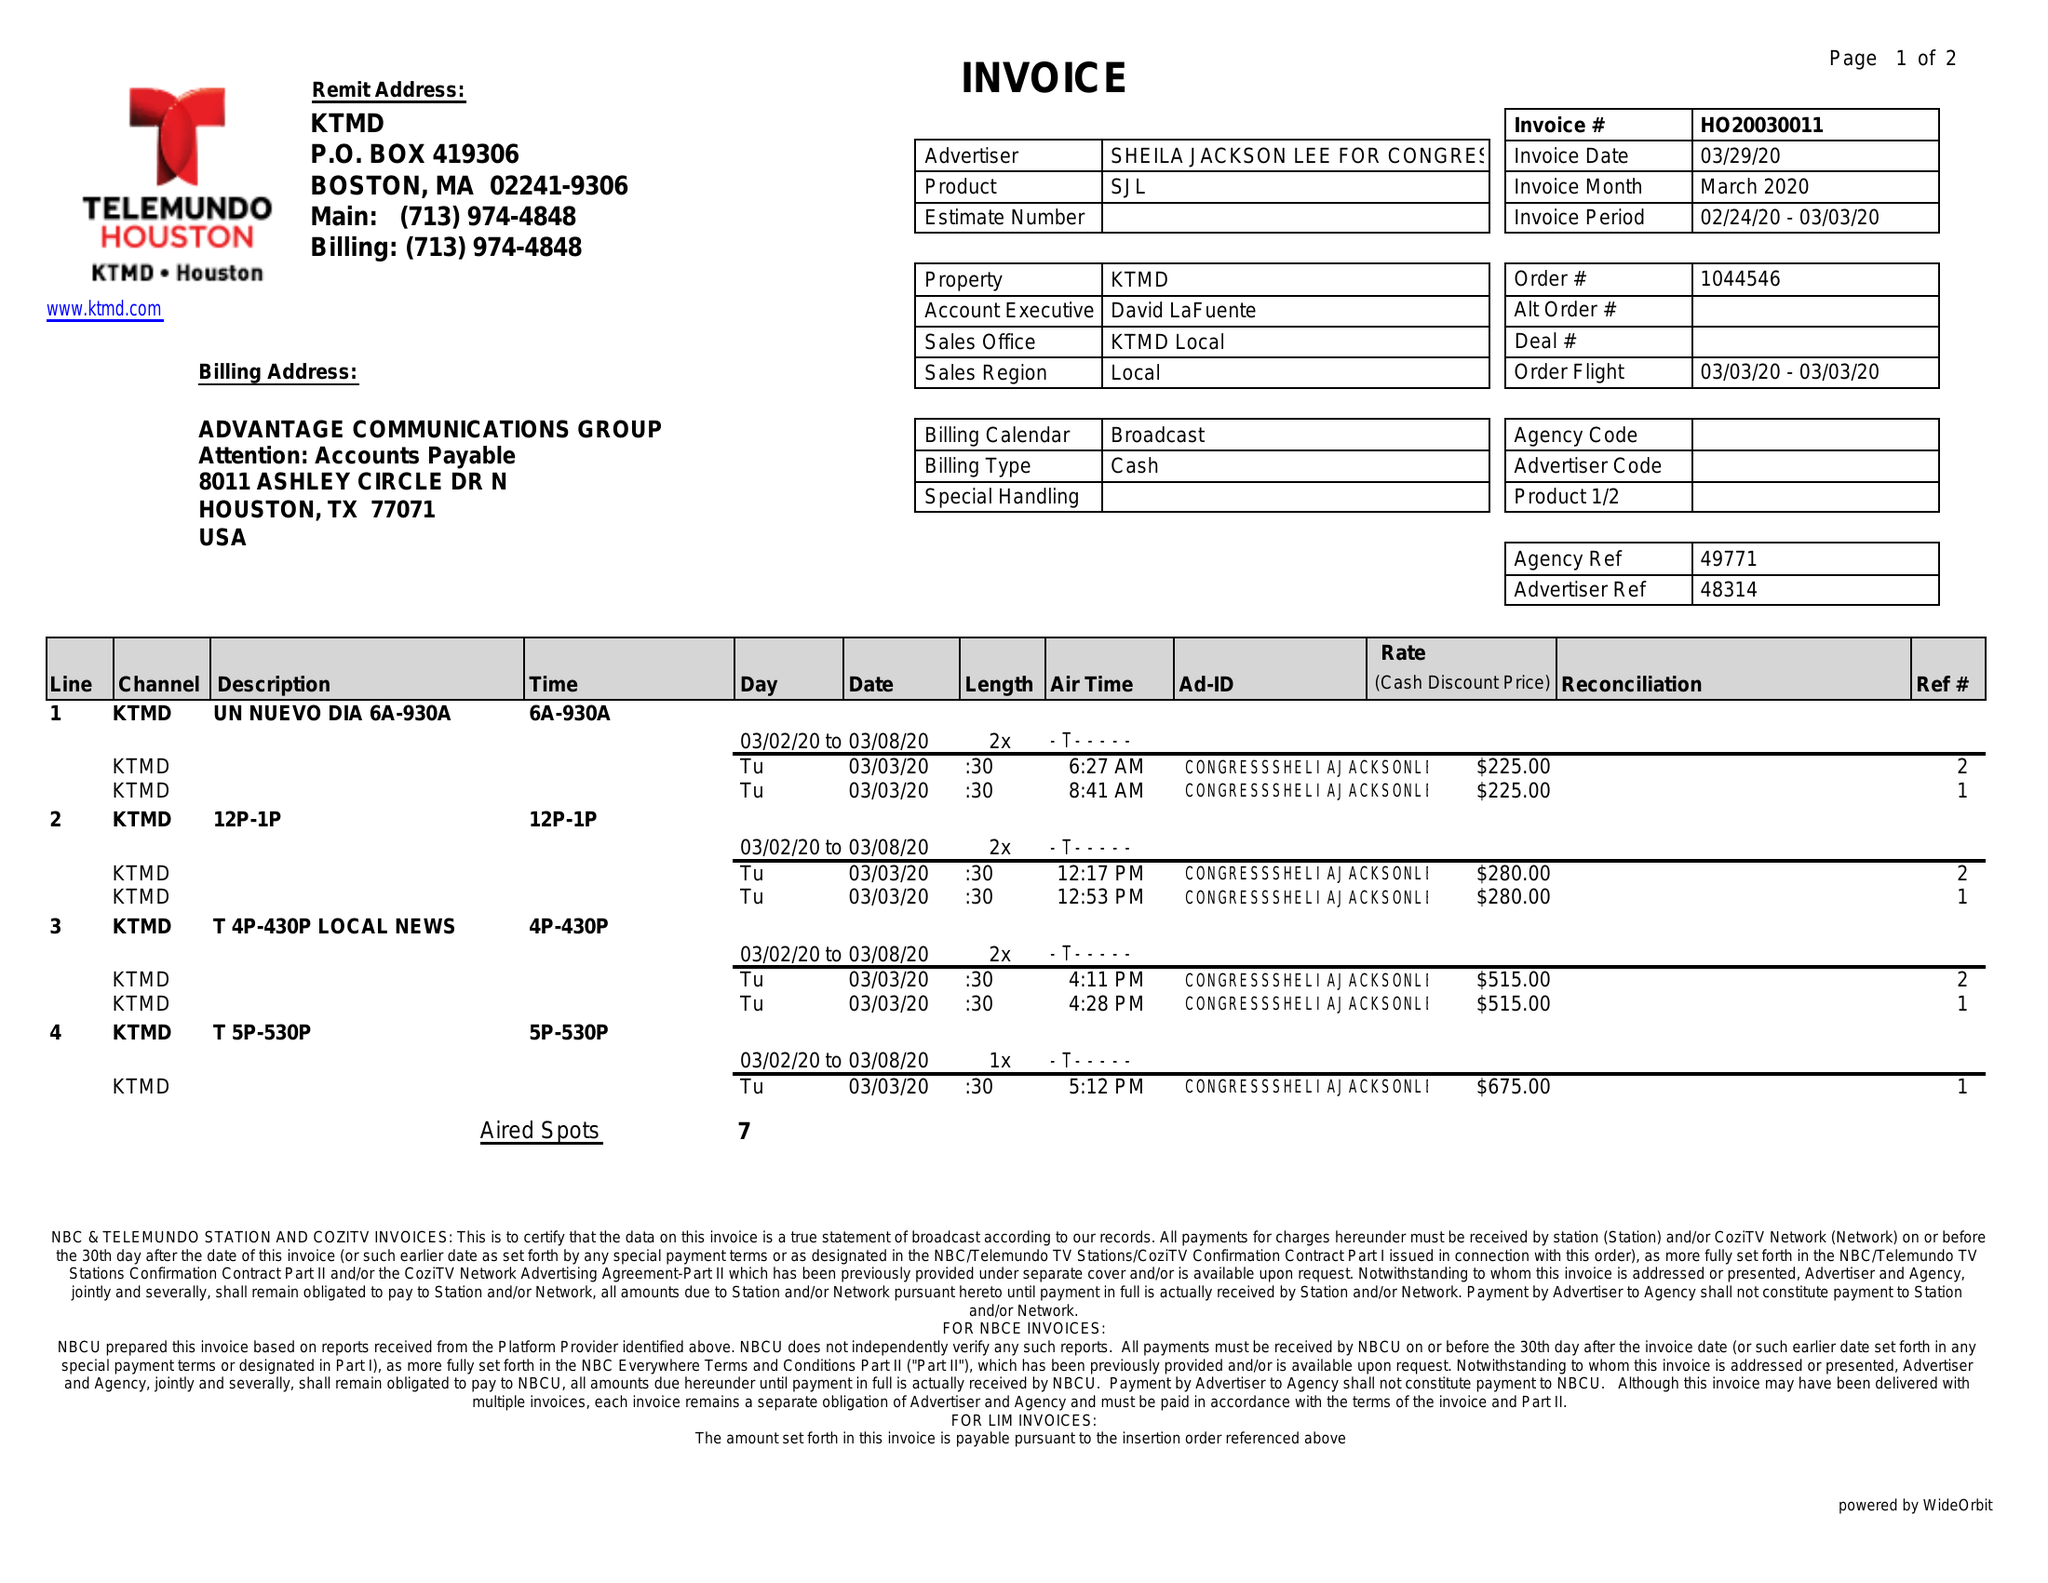What is the value for the advertiser?
Answer the question using a single word or phrase. SHEILA JACKSON LEE FOR CONGRESS 